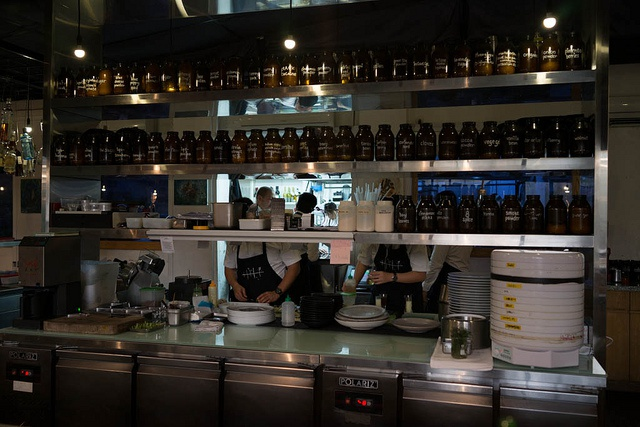Describe the objects in this image and their specific colors. I can see people in black, maroon, and gray tones, people in black, gray, and maroon tones, oven in black, gray, and maroon tones, cup in black and gray tones, and people in black and gray tones in this image. 